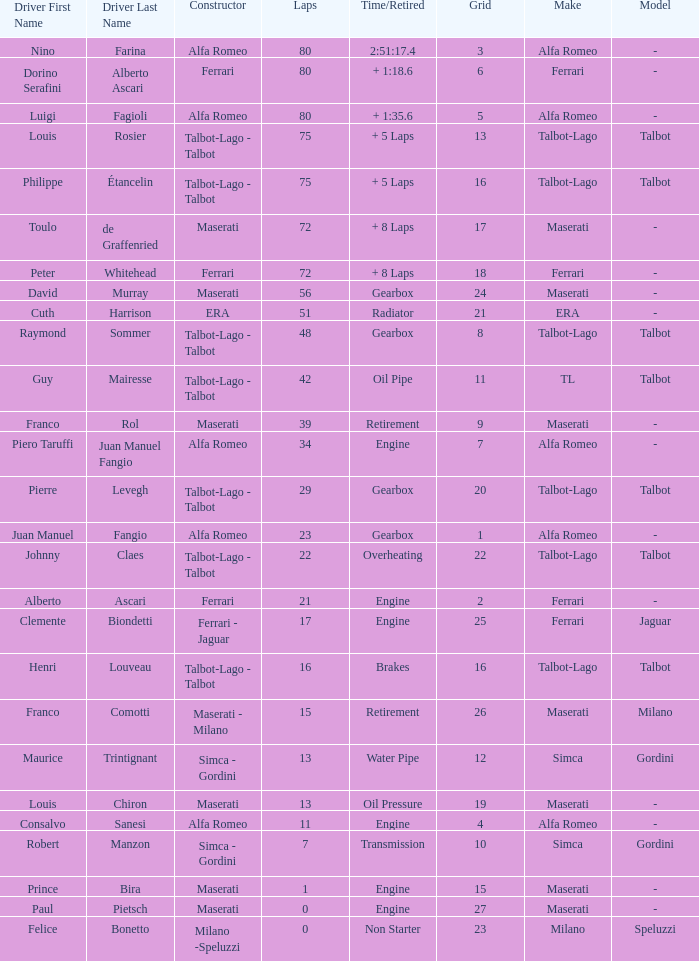When the driver is Juan Manuel Fangio and laps is less than 39, what is the highest grid? 1.0. 